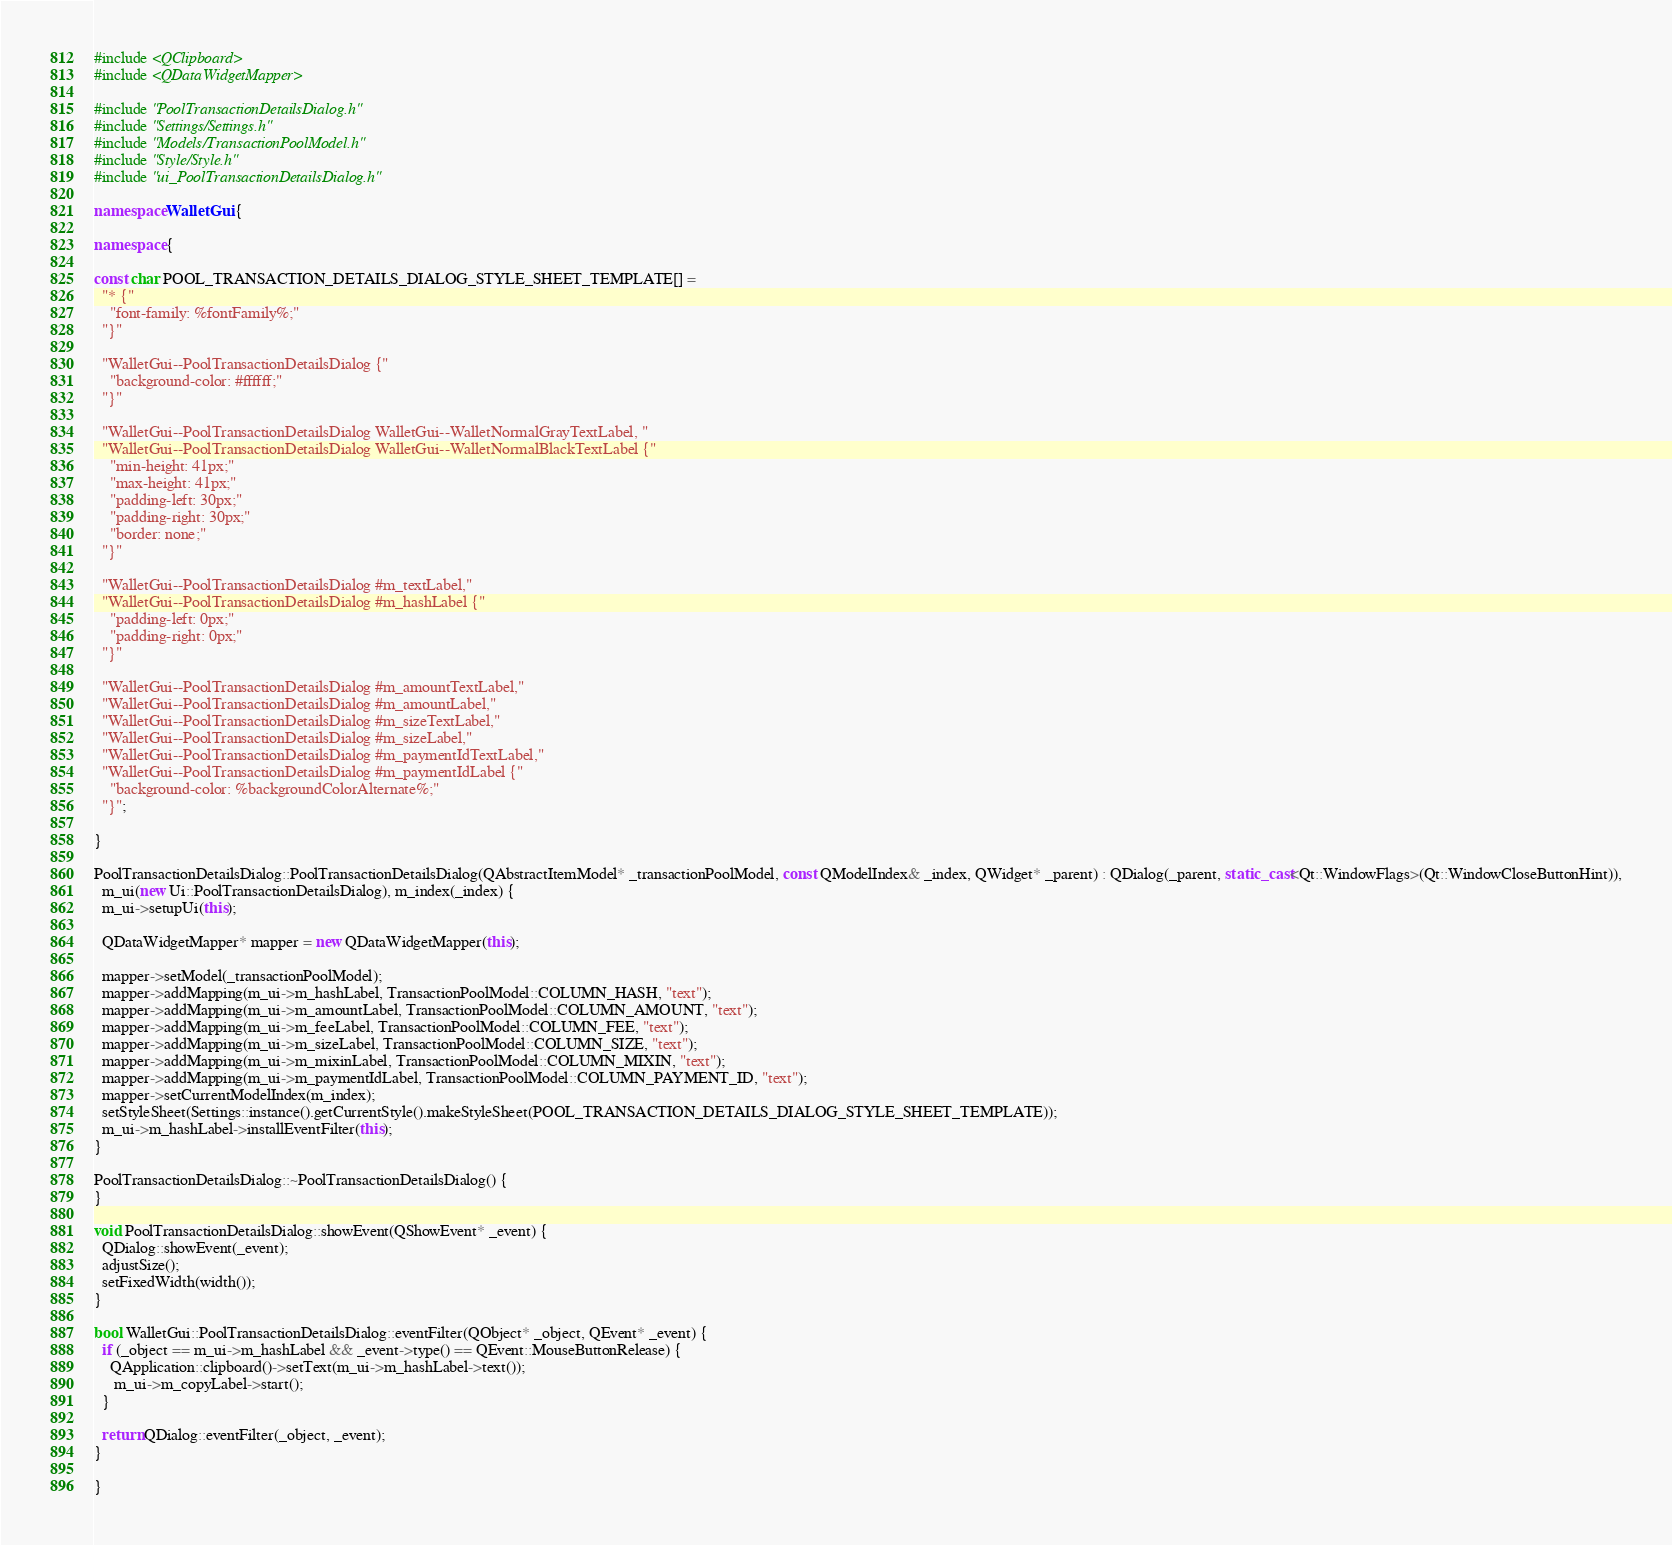Convert code to text. <code><loc_0><loc_0><loc_500><loc_500><_C++_>#include <QClipboard>
#include <QDataWidgetMapper>

#include "PoolTransactionDetailsDialog.h"
#include "Settings/Settings.h"
#include "Models/TransactionPoolModel.h"
#include "Style/Style.h"
#include "ui_PoolTransactionDetailsDialog.h"

namespace WalletGui {

namespace {

const char POOL_TRANSACTION_DETAILS_DIALOG_STYLE_SHEET_TEMPLATE[] =
  "* {"
    "font-family: %fontFamily%;"
  "}"

  "WalletGui--PoolTransactionDetailsDialog {"
    "background-color: #ffffff;"
  "}"

  "WalletGui--PoolTransactionDetailsDialog WalletGui--WalletNormalGrayTextLabel, "
  "WalletGui--PoolTransactionDetailsDialog WalletGui--WalletNormalBlackTextLabel {"
    "min-height: 41px;"
    "max-height: 41px;"
    "padding-left: 30px;"
    "padding-right: 30px;"
    "border: none;"
  "}"

  "WalletGui--PoolTransactionDetailsDialog #m_textLabel,"
  "WalletGui--PoolTransactionDetailsDialog #m_hashLabel {"
    "padding-left: 0px;"
    "padding-right: 0px;"
  "}"

  "WalletGui--PoolTransactionDetailsDialog #m_amountTextLabel,"
  "WalletGui--PoolTransactionDetailsDialog #m_amountLabel,"
  "WalletGui--PoolTransactionDetailsDialog #m_sizeTextLabel,"
  "WalletGui--PoolTransactionDetailsDialog #m_sizeLabel,"
  "WalletGui--PoolTransactionDetailsDialog #m_paymentIdTextLabel,"
  "WalletGui--PoolTransactionDetailsDialog #m_paymentIdLabel {"
    "background-color: %backgroundColorAlternate%;"
  "}";

}

PoolTransactionDetailsDialog::PoolTransactionDetailsDialog(QAbstractItemModel* _transactionPoolModel, const QModelIndex& _index, QWidget* _parent) : QDialog(_parent, static_cast<Qt::WindowFlags>(Qt::WindowCloseButtonHint)),
  m_ui(new Ui::PoolTransactionDetailsDialog), m_index(_index) {
  m_ui->setupUi(this);

  QDataWidgetMapper* mapper = new QDataWidgetMapper(this);

  mapper->setModel(_transactionPoolModel);
  mapper->addMapping(m_ui->m_hashLabel, TransactionPoolModel::COLUMN_HASH, "text");
  mapper->addMapping(m_ui->m_amountLabel, TransactionPoolModel::COLUMN_AMOUNT, "text");
  mapper->addMapping(m_ui->m_feeLabel, TransactionPoolModel::COLUMN_FEE, "text");
  mapper->addMapping(m_ui->m_sizeLabel, TransactionPoolModel::COLUMN_SIZE, "text");
  mapper->addMapping(m_ui->m_mixinLabel, TransactionPoolModel::COLUMN_MIXIN, "text");
  mapper->addMapping(m_ui->m_paymentIdLabel, TransactionPoolModel::COLUMN_PAYMENT_ID, "text");
  mapper->setCurrentModelIndex(m_index);
  setStyleSheet(Settings::instance().getCurrentStyle().makeStyleSheet(POOL_TRANSACTION_DETAILS_DIALOG_STYLE_SHEET_TEMPLATE));
  m_ui->m_hashLabel->installEventFilter(this);
}

PoolTransactionDetailsDialog::~PoolTransactionDetailsDialog() {
}

void PoolTransactionDetailsDialog::showEvent(QShowEvent* _event) {
  QDialog::showEvent(_event);
  adjustSize();
  setFixedWidth(width());
}

bool WalletGui::PoolTransactionDetailsDialog::eventFilter(QObject* _object, QEvent* _event) {
  if (_object == m_ui->m_hashLabel && _event->type() == QEvent::MouseButtonRelease) {
    QApplication::clipboard()->setText(m_ui->m_hashLabel->text());
     m_ui->m_copyLabel->start();
  }

  return QDialog::eventFilter(_object, _event);
}

}
</code> 